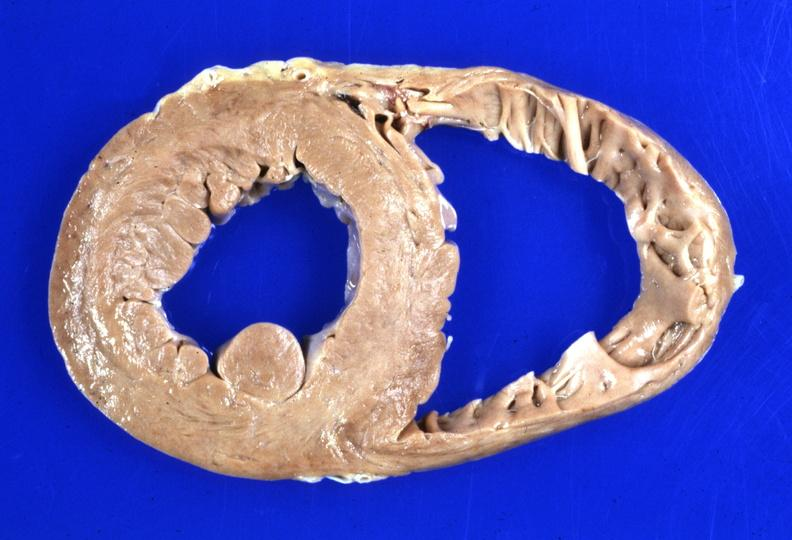s cachexia present?
Answer the question using a single word or phrase. No 